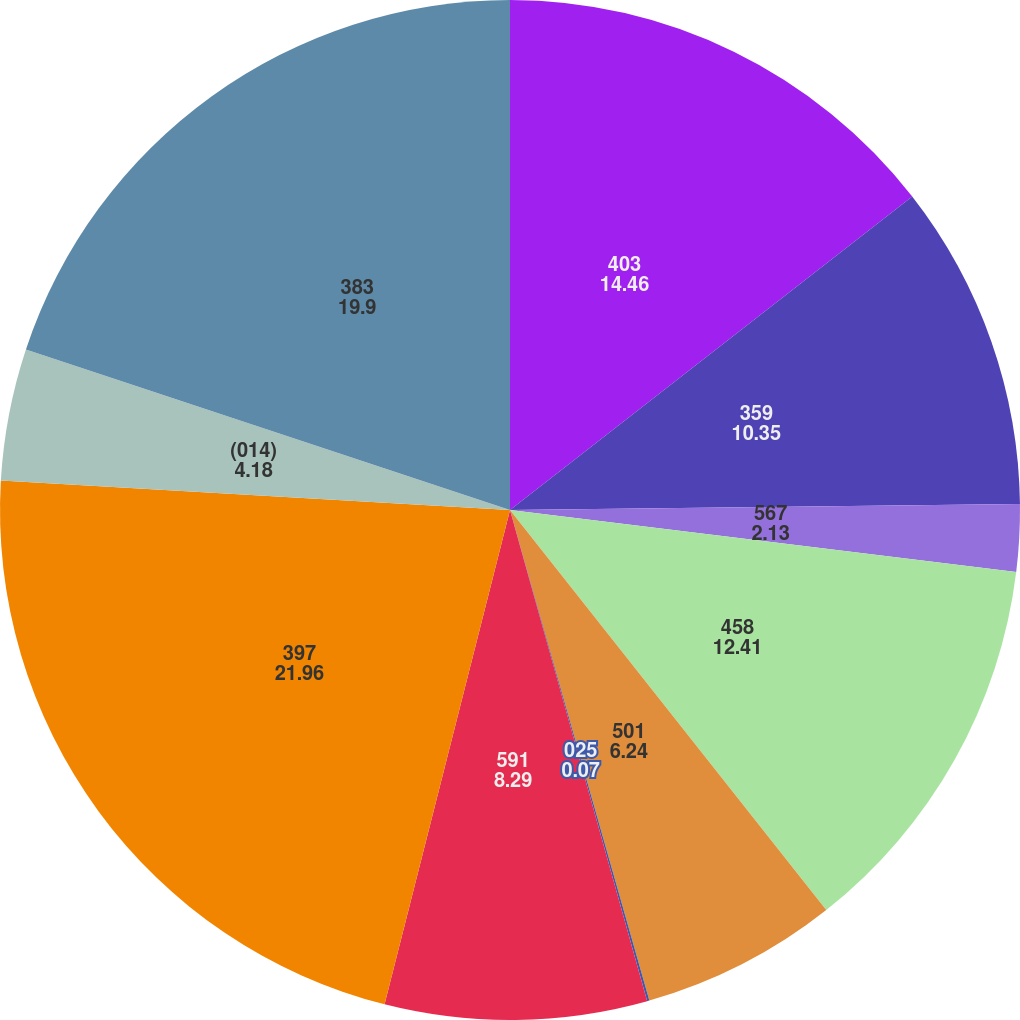Convert chart. <chart><loc_0><loc_0><loc_500><loc_500><pie_chart><fcel>403<fcel>359<fcel>567<fcel>458<fcel>501<fcel>025<fcel>591<fcel>397<fcel>(014)<fcel>383<nl><fcel>14.46%<fcel>10.35%<fcel>2.13%<fcel>12.41%<fcel>6.24%<fcel>0.07%<fcel>8.29%<fcel>21.96%<fcel>4.18%<fcel>19.9%<nl></chart> 